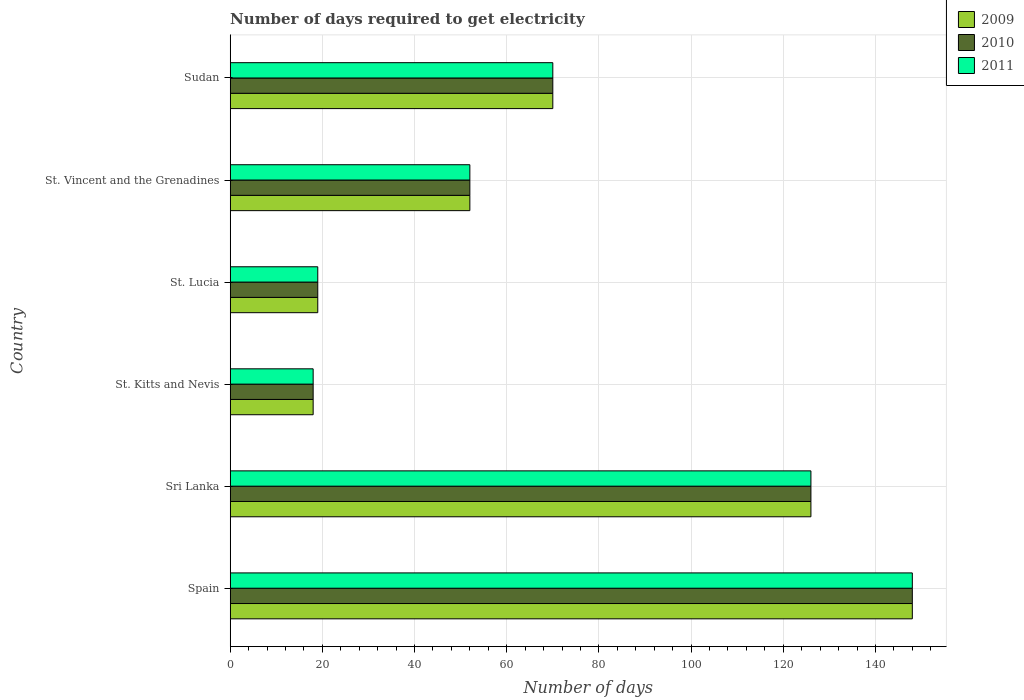How many different coloured bars are there?
Keep it short and to the point. 3. Are the number of bars on each tick of the Y-axis equal?
Provide a short and direct response. Yes. How many bars are there on the 4th tick from the top?
Your answer should be very brief. 3. What is the label of the 5th group of bars from the top?
Provide a short and direct response. Sri Lanka. What is the number of days required to get electricity in in 2010 in St. Kitts and Nevis?
Provide a short and direct response. 18. Across all countries, what is the maximum number of days required to get electricity in in 2010?
Provide a succinct answer. 148. In which country was the number of days required to get electricity in in 2010 maximum?
Give a very brief answer. Spain. In which country was the number of days required to get electricity in in 2011 minimum?
Offer a terse response. St. Kitts and Nevis. What is the total number of days required to get electricity in in 2010 in the graph?
Your answer should be compact. 433. What is the difference between the number of days required to get electricity in in 2010 in Sri Lanka and that in St. Vincent and the Grenadines?
Provide a succinct answer. 74. What is the average number of days required to get electricity in in 2011 per country?
Provide a succinct answer. 72.17. In how many countries, is the number of days required to get electricity in in 2009 greater than 124 days?
Offer a terse response. 2. What is the ratio of the number of days required to get electricity in in 2011 in St. Kitts and Nevis to that in St. Vincent and the Grenadines?
Your answer should be compact. 0.35. What is the difference between the highest and the lowest number of days required to get electricity in in 2011?
Provide a short and direct response. 130. In how many countries, is the number of days required to get electricity in in 2011 greater than the average number of days required to get electricity in in 2011 taken over all countries?
Offer a terse response. 2. Is the sum of the number of days required to get electricity in in 2011 in Spain and St. Lucia greater than the maximum number of days required to get electricity in in 2009 across all countries?
Provide a succinct answer. Yes. What does the 2nd bar from the bottom in St. Lucia represents?
Make the answer very short. 2010. Are all the bars in the graph horizontal?
Provide a succinct answer. Yes. How many legend labels are there?
Give a very brief answer. 3. How are the legend labels stacked?
Provide a short and direct response. Vertical. What is the title of the graph?
Your response must be concise. Number of days required to get electricity. What is the label or title of the X-axis?
Your response must be concise. Number of days. What is the Number of days of 2009 in Spain?
Make the answer very short. 148. What is the Number of days of 2010 in Spain?
Offer a terse response. 148. What is the Number of days of 2011 in Spain?
Your response must be concise. 148. What is the Number of days in 2009 in Sri Lanka?
Your answer should be compact. 126. What is the Number of days in 2010 in Sri Lanka?
Make the answer very short. 126. What is the Number of days in 2011 in Sri Lanka?
Offer a terse response. 126. What is the Number of days in 2009 in St. Kitts and Nevis?
Your answer should be compact. 18. What is the Number of days of 2010 in St. Kitts and Nevis?
Provide a succinct answer. 18. What is the Number of days in 2009 in St. Lucia?
Give a very brief answer. 19. What is the Number of days in 2010 in St. Lucia?
Your response must be concise. 19. What is the Number of days of 2010 in St. Vincent and the Grenadines?
Offer a very short reply. 52. What is the Number of days in 2009 in Sudan?
Offer a very short reply. 70. What is the Number of days of 2011 in Sudan?
Give a very brief answer. 70. Across all countries, what is the maximum Number of days of 2009?
Your answer should be very brief. 148. Across all countries, what is the maximum Number of days of 2010?
Offer a terse response. 148. Across all countries, what is the maximum Number of days of 2011?
Keep it short and to the point. 148. Across all countries, what is the minimum Number of days in 2009?
Provide a short and direct response. 18. What is the total Number of days in 2009 in the graph?
Your answer should be compact. 433. What is the total Number of days in 2010 in the graph?
Make the answer very short. 433. What is the total Number of days of 2011 in the graph?
Make the answer very short. 433. What is the difference between the Number of days in 2011 in Spain and that in Sri Lanka?
Make the answer very short. 22. What is the difference between the Number of days of 2009 in Spain and that in St. Kitts and Nevis?
Your answer should be very brief. 130. What is the difference between the Number of days of 2010 in Spain and that in St. Kitts and Nevis?
Keep it short and to the point. 130. What is the difference between the Number of days in 2011 in Spain and that in St. Kitts and Nevis?
Offer a very short reply. 130. What is the difference between the Number of days of 2009 in Spain and that in St. Lucia?
Provide a succinct answer. 129. What is the difference between the Number of days in 2010 in Spain and that in St. Lucia?
Offer a very short reply. 129. What is the difference between the Number of days of 2011 in Spain and that in St. Lucia?
Provide a succinct answer. 129. What is the difference between the Number of days of 2009 in Spain and that in St. Vincent and the Grenadines?
Your answer should be compact. 96. What is the difference between the Number of days of 2010 in Spain and that in St. Vincent and the Grenadines?
Your answer should be compact. 96. What is the difference between the Number of days of 2011 in Spain and that in St. Vincent and the Grenadines?
Provide a succinct answer. 96. What is the difference between the Number of days of 2010 in Spain and that in Sudan?
Make the answer very short. 78. What is the difference between the Number of days in 2011 in Spain and that in Sudan?
Your answer should be very brief. 78. What is the difference between the Number of days of 2009 in Sri Lanka and that in St. Kitts and Nevis?
Your answer should be compact. 108. What is the difference between the Number of days in 2010 in Sri Lanka and that in St. Kitts and Nevis?
Ensure brevity in your answer.  108. What is the difference between the Number of days of 2011 in Sri Lanka and that in St. Kitts and Nevis?
Your answer should be compact. 108. What is the difference between the Number of days in 2009 in Sri Lanka and that in St. Lucia?
Provide a short and direct response. 107. What is the difference between the Number of days in 2010 in Sri Lanka and that in St. Lucia?
Keep it short and to the point. 107. What is the difference between the Number of days in 2011 in Sri Lanka and that in St. Lucia?
Keep it short and to the point. 107. What is the difference between the Number of days of 2010 in St. Kitts and Nevis and that in St. Lucia?
Ensure brevity in your answer.  -1. What is the difference between the Number of days of 2009 in St. Kitts and Nevis and that in St. Vincent and the Grenadines?
Make the answer very short. -34. What is the difference between the Number of days in 2010 in St. Kitts and Nevis and that in St. Vincent and the Grenadines?
Give a very brief answer. -34. What is the difference between the Number of days in 2011 in St. Kitts and Nevis and that in St. Vincent and the Grenadines?
Your answer should be compact. -34. What is the difference between the Number of days of 2009 in St. Kitts and Nevis and that in Sudan?
Your answer should be compact. -52. What is the difference between the Number of days in 2010 in St. Kitts and Nevis and that in Sudan?
Provide a succinct answer. -52. What is the difference between the Number of days of 2011 in St. Kitts and Nevis and that in Sudan?
Provide a succinct answer. -52. What is the difference between the Number of days in 2009 in St. Lucia and that in St. Vincent and the Grenadines?
Give a very brief answer. -33. What is the difference between the Number of days of 2010 in St. Lucia and that in St. Vincent and the Grenadines?
Keep it short and to the point. -33. What is the difference between the Number of days in 2011 in St. Lucia and that in St. Vincent and the Grenadines?
Offer a terse response. -33. What is the difference between the Number of days in 2009 in St. Lucia and that in Sudan?
Offer a terse response. -51. What is the difference between the Number of days in 2010 in St. Lucia and that in Sudan?
Your answer should be very brief. -51. What is the difference between the Number of days of 2011 in St. Lucia and that in Sudan?
Offer a terse response. -51. What is the difference between the Number of days in 2009 in St. Vincent and the Grenadines and that in Sudan?
Your answer should be compact. -18. What is the difference between the Number of days in 2010 in St. Vincent and the Grenadines and that in Sudan?
Offer a terse response. -18. What is the difference between the Number of days of 2009 in Spain and the Number of days of 2010 in St. Kitts and Nevis?
Your answer should be very brief. 130. What is the difference between the Number of days in 2009 in Spain and the Number of days in 2011 in St. Kitts and Nevis?
Give a very brief answer. 130. What is the difference between the Number of days in 2010 in Spain and the Number of days in 2011 in St. Kitts and Nevis?
Offer a very short reply. 130. What is the difference between the Number of days in 2009 in Spain and the Number of days in 2010 in St. Lucia?
Provide a short and direct response. 129. What is the difference between the Number of days of 2009 in Spain and the Number of days of 2011 in St. Lucia?
Offer a terse response. 129. What is the difference between the Number of days in 2010 in Spain and the Number of days in 2011 in St. Lucia?
Keep it short and to the point. 129. What is the difference between the Number of days in 2009 in Spain and the Number of days in 2010 in St. Vincent and the Grenadines?
Your answer should be compact. 96. What is the difference between the Number of days in 2009 in Spain and the Number of days in 2011 in St. Vincent and the Grenadines?
Make the answer very short. 96. What is the difference between the Number of days in 2010 in Spain and the Number of days in 2011 in St. Vincent and the Grenadines?
Keep it short and to the point. 96. What is the difference between the Number of days in 2009 in Spain and the Number of days in 2011 in Sudan?
Your answer should be very brief. 78. What is the difference between the Number of days of 2009 in Sri Lanka and the Number of days of 2010 in St. Kitts and Nevis?
Keep it short and to the point. 108. What is the difference between the Number of days of 2009 in Sri Lanka and the Number of days of 2011 in St. Kitts and Nevis?
Offer a terse response. 108. What is the difference between the Number of days in 2010 in Sri Lanka and the Number of days in 2011 in St. Kitts and Nevis?
Make the answer very short. 108. What is the difference between the Number of days of 2009 in Sri Lanka and the Number of days of 2010 in St. Lucia?
Your answer should be compact. 107. What is the difference between the Number of days in 2009 in Sri Lanka and the Number of days in 2011 in St. Lucia?
Offer a very short reply. 107. What is the difference between the Number of days of 2010 in Sri Lanka and the Number of days of 2011 in St. Lucia?
Offer a terse response. 107. What is the difference between the Number of days in 2009 in Sri Lanka and the Number of days in 2010 in St. Vincent and the Grenadines?
Provide a succinct answer. 74. What is the difference between the Number of days of 2009 in Sri Lanka and the Number of days of 2011 in St. Vincent and the Grenadines?
Provide a short and direct response. 74. What is the difference between the Number of days of 2010 in Sri Lanka and the Number of days of 2011 in St. Vincent and the Grenadines?
Keep it short and to the point. 74. What is the difference between the Number of days of 2009 in Sri Lanka and the Number of days of 2011 in Sudan?
Your answer should be very brief. 56. What is the difference between the Number of days in 2010 in Sri Lanka and the Number of days in 2011 in Sudan?
Provide a short and direct response. 56. What is the difference between the Number of days in 2009 in St. Kitts and Nevis and the Number of days in 2011 in St. Lucia?
Ensure brevity in your answer.  -1. What is the difference between the Number of days in 2009 in St. Kitts and Nevis and the Number of days in 2010 in St. Vincent and the Grenadines?
Keep it short and to the point. -34. What is the difference between the Number of days in 2009 in St. Kitts and Nevis and the Number of days in 2011 in St. Vincent and the Grenadines?
Your response must be concise. -34. What is the difference between the Number of days of 2010 in St. Kitts and Nevis and the Number of days of 2011 in St. Vincent and the Grenadines?
Offer a terse response. -34. What is the difference between the Number of days of 2009 in St. Kitts and Nevis and the Number of days of 2010 in Sudan?
Your answer should be very brief. -52. What is the difference between the Number of days in 2009 in St. Kitts and Nevis and the Number of days in 2011 in Sudan?
Keep it short and to the point. -52. What is the difference between the Number of days in 2010 in St. Kitts and Nevis and the Number of days in 2011 in Sudan?
Your answer should be compact. -52. What is the difference between the Number of days of 2009 in St. Lucia and the Number of days of 2010 in St. Vincent and the Grenadines?
Provide a short and direct response. -33. What is the difference between the Number of days in 2009 in St. Lucia and the Number of days in 2011 in St. Vincent and the Grenadines?
Offer a very short reply. -33. What is the difference between the Number of days in 2010 in St. Lucia and the Number of days in 2011 in St. Vincent and the Grenadines?
Provide a short and direct response. -33. What is the difference between the Number of days of 2009 in St. Lucia and the Number of days of 2010 in Sudan?
Offer a terse response. -51. What is the difference between the Number of days in 2009 in St. Lucia and the Number of days in 2011 in Sudan?
Offer a very short reply. -51. What is the difference between the Number of days in 2010 in St. Lucia and the Number of days in 2011 in Sudan?
Make the answer very short. -51. What is the difference between the Number of days of 2009 in St. Vincent and the Grenadines and the Number of days of 2011 in Sudan?
Keep it short and to the point. -18. What is the average Number of days of 2009 per country?
Provide a succinct answer. 72.17. What is the average Number of days in 2010 per country?
Keep it short and to the point. 72.17. What is the average Number of days of 2011 per country?
Make the answer very short. 72.17. What is the difference between the Number of days of 2009 and Number of days of 2010 in Spain?
Ensure brevity in your answer.  0. What is the difference between the Number of days in 2009 and Number of days in 2011 in Spain?
Provide a short and direct response. 0. What is the difference between the Number of days of 2009 and Number of days of 2010 in Sri Lanka?
Offer a terse response. 0. What is the difference between the Number of days in 2009 and Number of days in 2011 in Sri Lanka?
Keep it short and to the point. 0. What is the difference between the Number of days in 2009 and Number of days in 2010 in St. Kitts and Nevis?
Provide a short and direct response. 0. What is the difference between the Number of days of 2009 and Number of days of 2010 in St. Lucia?
Give a very brief answer. 0. What is the difference between the Number of days in 2010 and Number of days in 2011 in St. Lucia?
Make the answer very short. 0. What is the difference between the Number of days in 2009 and Number of days in 2010 in St. Vincent and the Grenadines?
Keep it short and to the point. 0. What is the difference between the Number of days of 2009 and Number of days of 2011 in St. Vincent and the Grenadines?
Offer a terse response. 0. What is the difference between the Number of days in 2009 and Number of days in 2010 in Sudan?
Keep it short and to the point. 0. What is the difference between the Number of days in 2010 and Number of days in 2011 in Sudan?
Give a very brief answer. 0. What is the ratio of the Number of days in 2009 in Spain to that in Sri Lanka?
Ensure brevity in your answer.  1.17. What is the ratio of the Number of days in 2010 in Spain to that in Sri Lanka?
Keep it short and to the point. 1.17. What is the ratio of the Number of days in 2011 in Spain to that in Sri Lanka?
Offer a very short reply. 1.17. What is the ratio of the Number of days of 2009 in Spain to that in St. Kitts and Nevis?
Offer a terse response. 8.22. What is the ratio of the Number of days in 2010 in Spain to that in St. Kitts and Nevis?
Ensure brevity in your answer.  8.22. What is the ratio of the Number of days of 2011 in Spain to that in St. Kitts and Nevis?
Offer a terse response. 8.22. What is the ratio of the Number of days in 2009 in Spain to that in St. Lucia?
Offer a very short reply. 7.79. What is the ratio of the Number of days in 2010 in Spain to that in St. Lucia?
Give a very brief answer. 7.79. What is the ratio of the Number of days in 2011 in Spain to that in St. Lucia?
Your answer should be compact. 7.79. What is the ratio of the Number of days in 2009 in Spain to that in St. Vincent and the Grenadines?
Provide a succinct answer. 2.85. What is the ratio of the Number of days in 2010 in Spain to that in St. Vincent and the Grenadines?
Provide a short and direct response. 2.85. What is the ratio of the Number of days in 2011 in Spain to that in St. Vincent and the Grenadines?
Provide a succinct answer. 2.85. What is the ratio of the Number of days of 2009 in Spain to that in Sudan?
Offer a terse response. 2.11. What is the ratio of the Number of days in 2010 in Spain to that in Sudan?
Your answer should be compact. 2.11. What is the ratio of the Number of days in 2011 in Spain to that in Sudan?
Give a very brief answer. 2.11. What is the ratio of the Number of days of 2009 in Sri Lanka to that in St. Lucia?
Provide a succinct answer. 6.63. What is the ratio of the Number of days of 2010 in Sri Lanka to that in St. Lucia?
Your answer should be compact. 6.63. What is the ratio of the Number of days of 2011 in Sri Lanka to that in St. Lucia?
Provide a short and direct response. 6.63. What is the ratio of the Number of days of 2009 in Sri Lanka to that in St. Vincent and the Grenadines?
Your answer should be compact. 2.42. What is the ratio of the Number of days of 2010 in Sri Lanka to that in St. Vincent and the Grenadines?
Make the answer very short. 2.42. What is the ratio of the Number of days in 2011 in Sri Lanka to that in St. Vincent and the Grenadines?
Ensure brevity in your answer.  2.42. What is the ratio of the Number of days in 2010 in Sri Lanka to that in Sudan?
Your response must be concise. 1.8. What is the ratio of the Number of days in 2009 in St. Kitts and Nevis to that in St. Vincent and the Grenadines?
Offer a very short reply. 0.35. What is the ratio of the Number of days in 2010 in St. Kitts and Nevis to that in St. Vincent and the Grenadines?
Make the answer very short. 0.35. What is the ratio of the Number of days of 2011 in St. Kitts and Nevis to that in St. Vincent and the Grenadines?
Your response must be concise. 0.35. What is the ratio of the Number of days of 2009 in St. Kitts and Nevis to that in Sudan?
Provide a succinct answer. 0.26. What is the ratio of the Number of days in 2010 in St. Kitts and Nevis to that in Sudan?
Keep it short and to the point. 0.26. What is the ratio of the Number of days of 2011 in St. Kitts and Nevis to that in Sudan?
Offer a very short reply. 0.26. What is the ratio of the Number of days of 2009 in St. Lucia to that in St. Vincent and the Grenadines?
Provide a short and direct response. 0.37. What is the ratio of the Number of days of 2010 in St. Lucia to that in St. Vincent and the Grenadines?
Give a very brief answer. 0.37. What is the ratio of the Number of days of 2011 in St. Lucia to that in St. Vincent and the Grenadines?
Ensure brevity in your answer.  0.37. What is the ratio of the Number of days of 2009 in St. Lucia to that in Sudan?
Provide a short and direct response. 0.27. What is the ratio of the Number of days in 2010 in St. Lucia to that in Sudan?
Make the answer very short. 0.27. What is the ratio of the Number of days of 2011 in St. Lucia to that in Sudan?
Ensure brevity in your answer.  0.27. What is the ratio of the Number of days of 2009 in St. Vincent and the Grenadines to that in Sudan?
Give a very brief answer. 0.74. What is the ratio of the Number of days of 2010 in St. Vincent and the Grenadines to that in Sudan?
Your response must be concise. 0.74. What is the ratio of the Number of days in 2011 in St. Vincent and the Grenadines to that in Sudan?
Offer a very short reply. 0.74. What is the difference between the highest and the second highest Number of days in 2011?
Offer a terse response. 22. What is the difference between the highest and the lowest Number of days of 2009?
Provide a short and direct response. 130. What is the difference between the highest and the lowest Number of days of 2010?
Offer a very short reply. 130. What is the difference between the highest and the lowest Number of days of 2011?
Your answer should be compact. 130. 